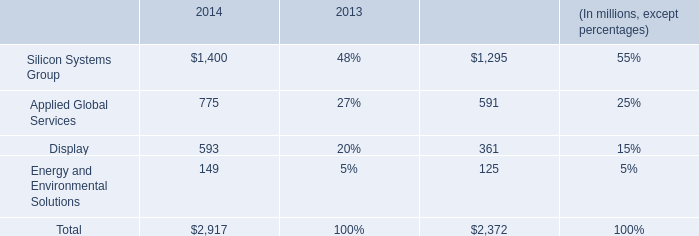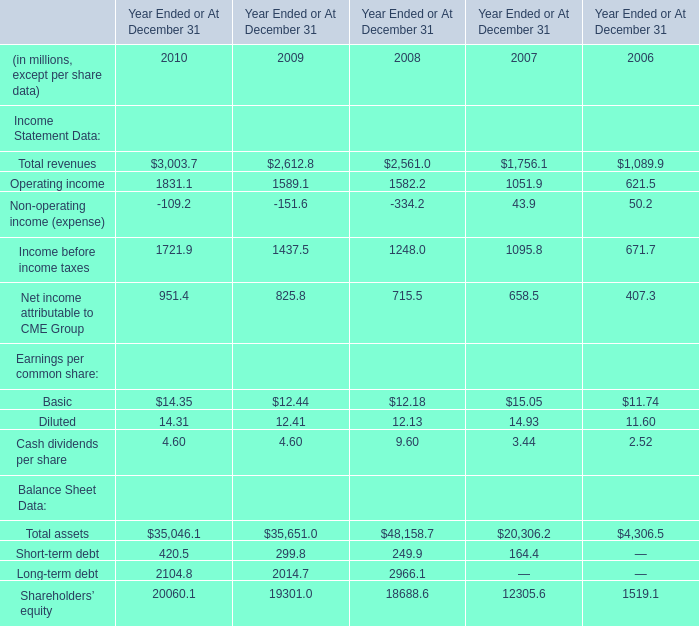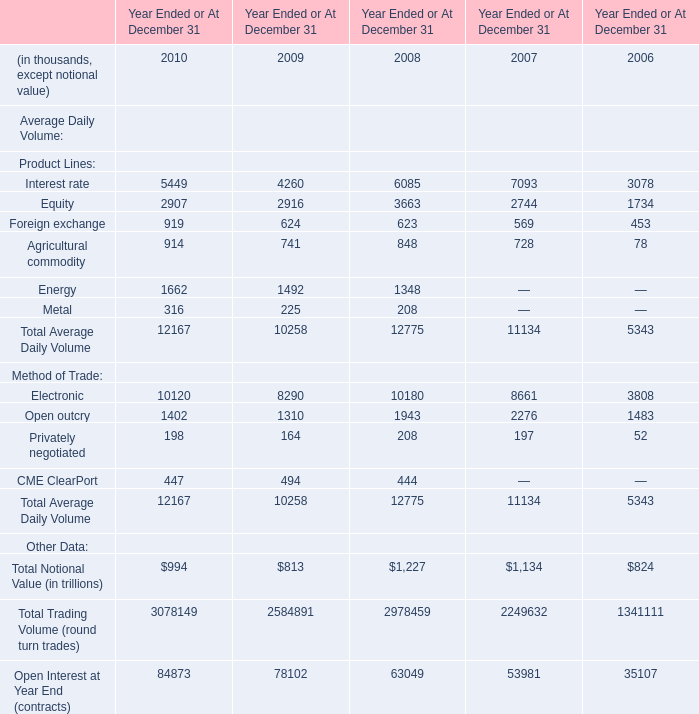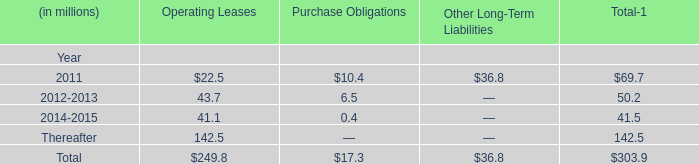Does Interest rate keeps increasing each year between 2009 and 2010 ? 
Answer: yes. 